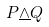Convert formula to latex. <formula><loc_0><loc_0><loc_500><loc_500>P \underline { \wedge } Q</formula> 